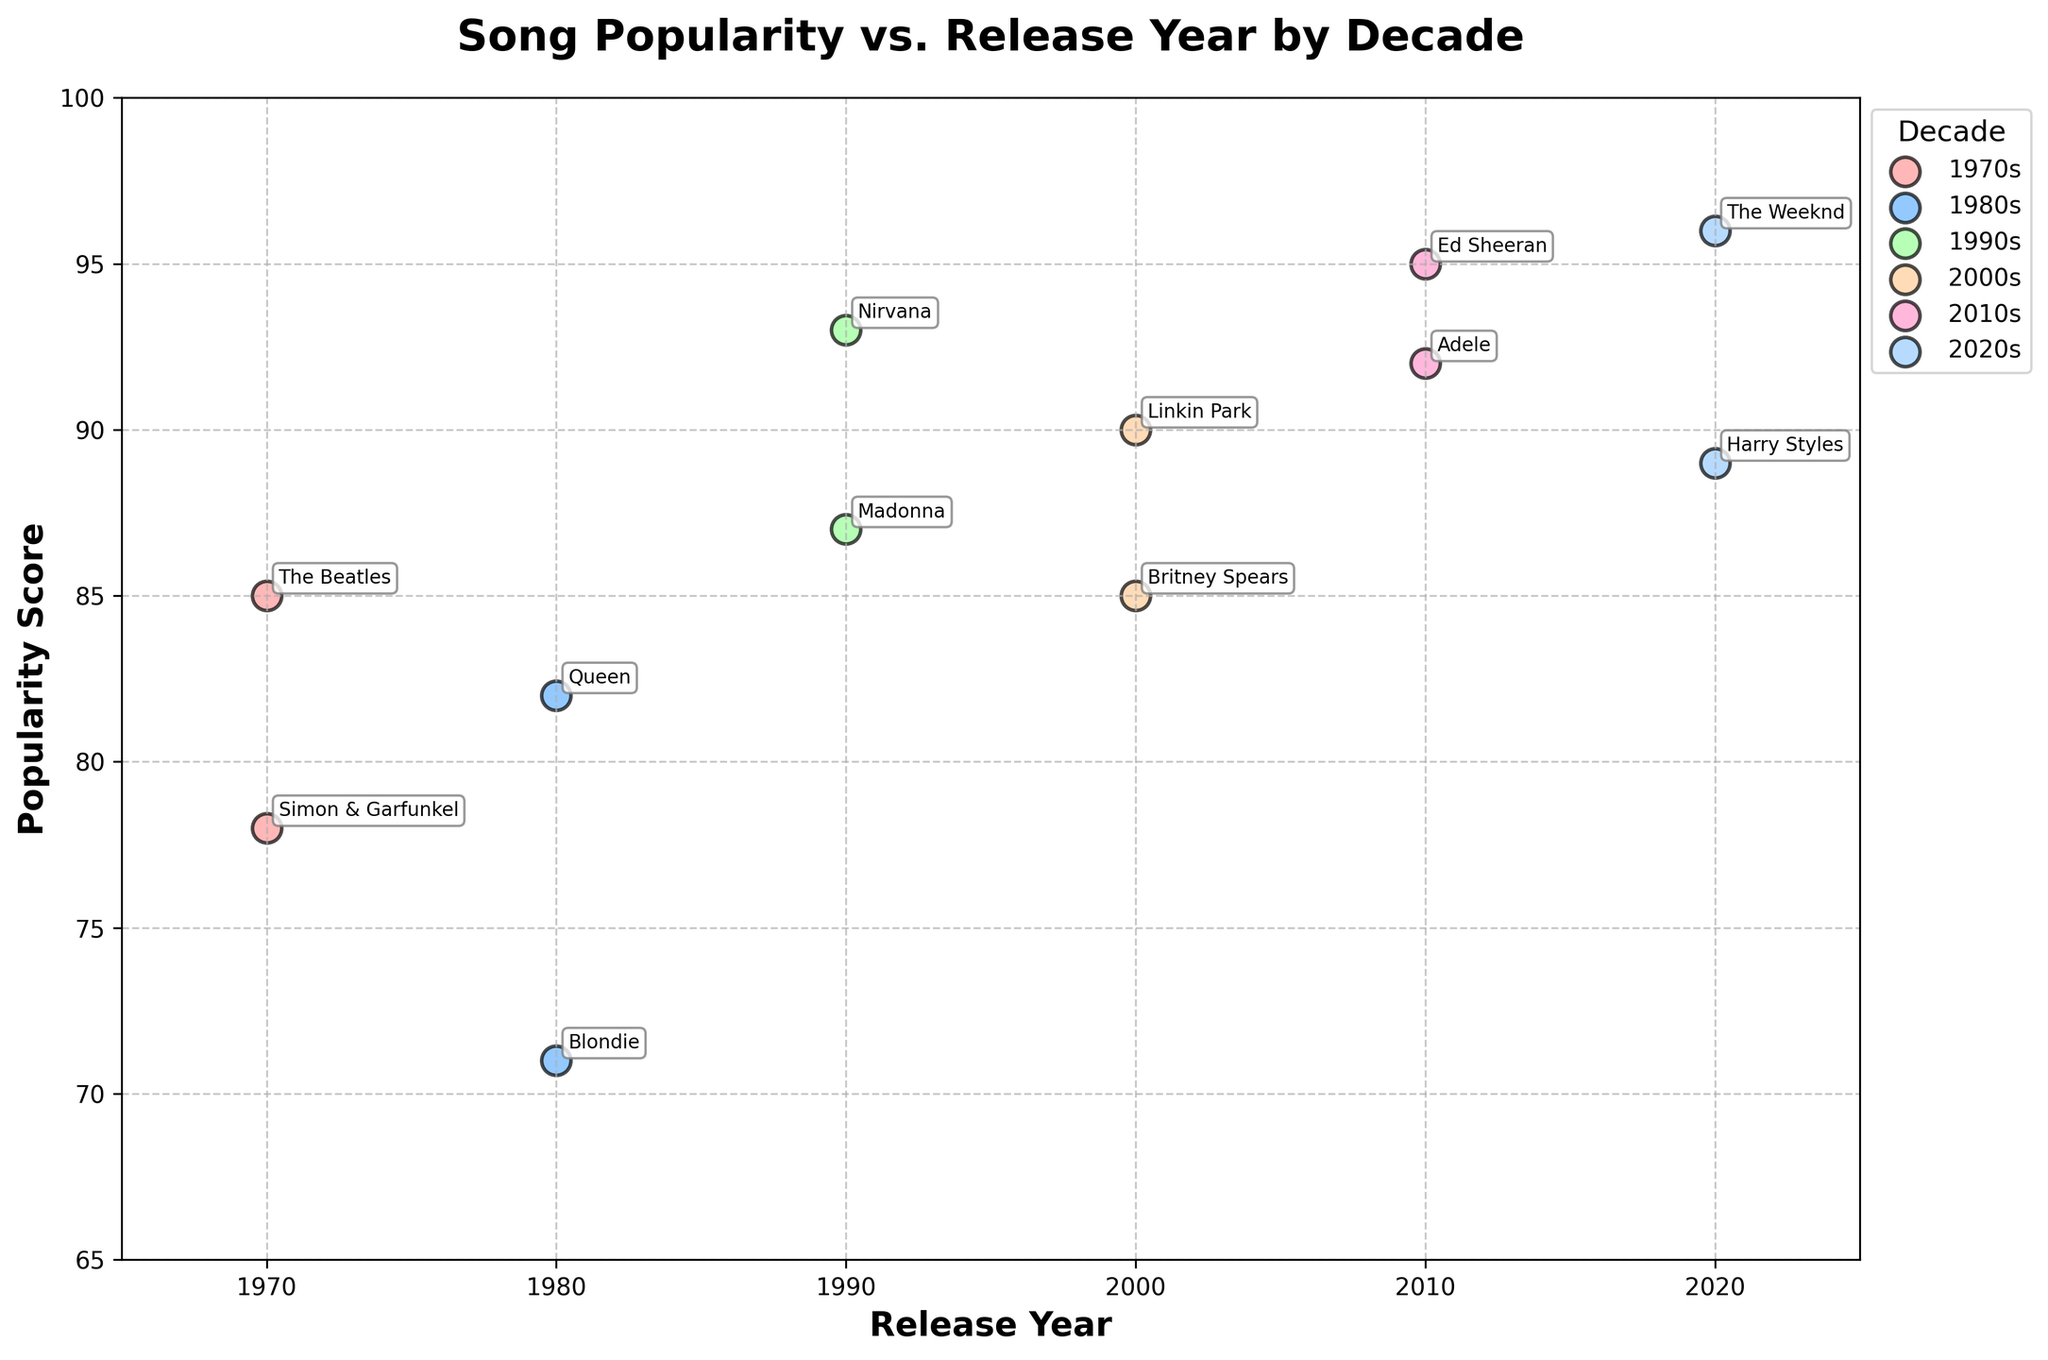What is the title of the scatter plot? The title is usually located at the top center of the plot. In this case, it says "Song Popularity vs. Release Year by Decade."
Answer: Song Popularity vs. Release Year by Decade How many different decades are represented in the scatter plot? By looking at the legend on the right side, we can see that different colors represent different decades. There are titles for six decades.
Answer: Six Which decade has the song with the highest popularity score? The highest popularity score is represented by the dot located at the top of the y-axis. The decade with the song "Shape of You" by Ed Sheeran represents the 2010s.
Answer: 2010s What is the popularity score of "Smells Like Teen Spirit" by Nirvana? By finding the annotation "Nirvana" in the scatter plot at the position corresponding to the 1990s, we can see the popularity score of the song.
Answer: 93 Which decade has the most spread in popularity scores? To determine this, we need to identify the range of popularity scores within each decade. The 2020s show a large range from "Blinding Lights" with 96 to "Watermelon Sugar" with 89, indicating the most spread.
Answer: 2020s What is the average popularity score of the songs released in the 1980s? Identify the two data points from the 1980s: "Another One Bites the Dust" by Queen with 82 and "Call Me" by Blondie with 71. The average is (82 + 71) / 2 = 76.5.
Answer: 76.5 Which decade does the song "Let It Be" by The Beatles belong to? Looking at the annotation "The Beatles," we can see that it belongs to the 1970s, indicated by the year and the specific color for this decade.
Answer: 1970s By how many points does the popularity score of "Rolling in the Deep" by Adele exceed that of "In the End" by Linkin Park? "Rolling in the Deep" has a score of 92, while "In the End" has a score of 90. The difference is 92 - 90 = 2 points.
Answer: 2 points Which song in the 2000s has the highest popularity score? Look at the annotations in the 2000s decade to find the song "In the End" by Linkin Park with the highest score of 90.
Answer: In the End, by Linkin Park Are there any songs with a popularity score of exactly 100? By scanning through the scatter plot, we observe the y-axis values and annotations. No data points reach a score of 100.
Answer: No 